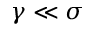<formula> <loc_0><loc_0><loc_500><loc_500>\gamma \ll \sigma</formula> 